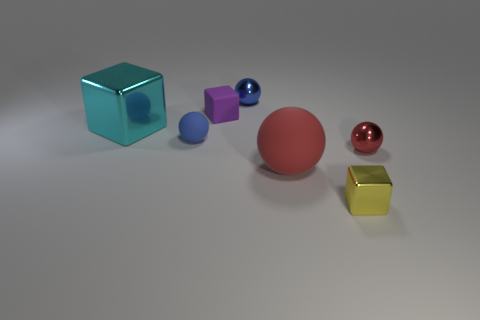What number of metallic spheres are right of the red metal sphere? There are no metallic spheres to the right of the red sphere. The composition consists of the red sphere on the rightmost side, flanked by a blue and a pink sphere to its left. 